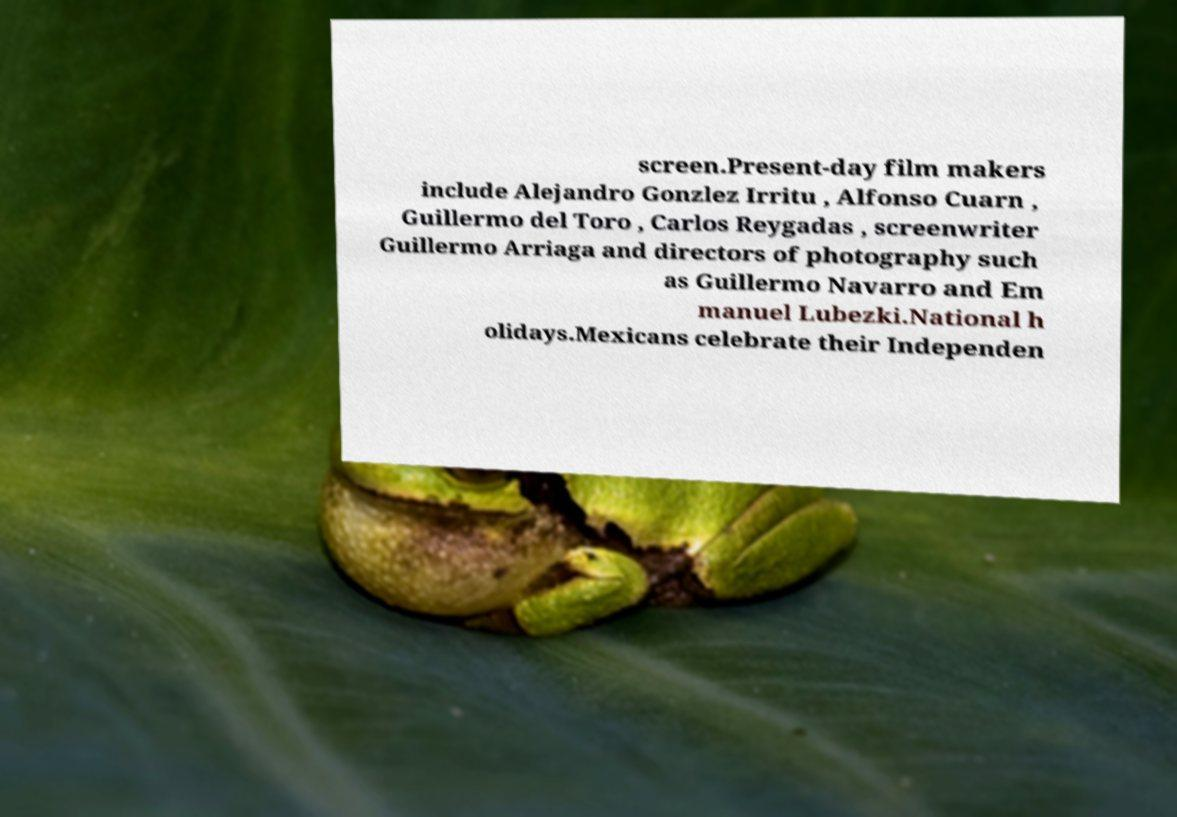Please identify and transcribe the text found in this image. screen.Present-day film makers include Alejandro Gonzlez Irritu , Alfonso Cuarn , Guillermo del Toro , Carlos Reygadas , screenwriter Guillermo Arriaga and directors of photography such as Guillermo Navarro and Em manuel Lubezki.National h olidays.Mexicans celebrate their Independen 